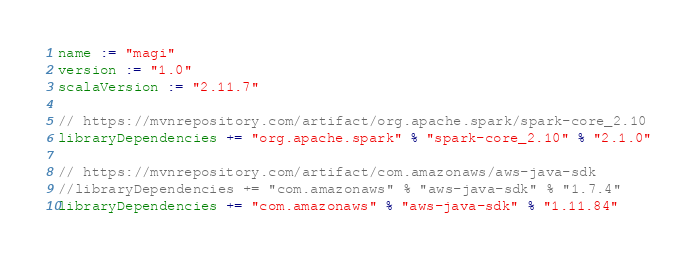<code> <loc_0><loc_0><loc_500><loc_500><_Scala_>name := "magi"
version := "1.0"
scalaVersion := "2.11.7"

// https://mvnrepository.com/artifact/org.apache.spark/spark-core_2.10
libraryDependencies += "org.apache.spark" % "spark-core_2.10" % "2.1.0"

// https://mvnrepository.com/artifact/com.amazonaws/aws-java-sdk
//libraryDependencies += "com.amazonaws" % "aws-java-sdk" % "1.7.4"
libraryDependencies += "com.amazonaws" % "aws-java-sdk" % "1.11.84"
</code> 